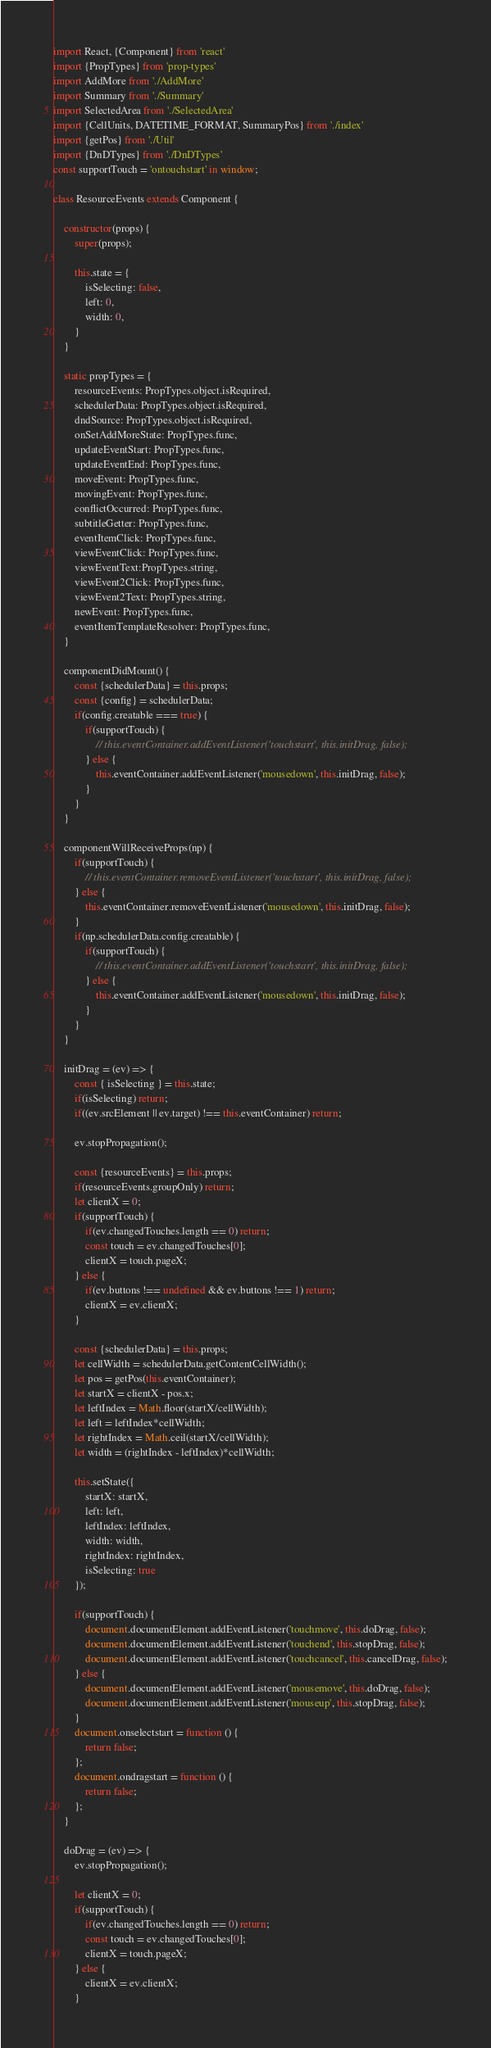<code> <loc_0><loc_0><loc_500><loc_500><_JavaScript_>import React, {Component} from 'react'
import {PropTypes} from 'prop-types'
import AddMore from './AddMore'
import Summary from './Summary'
import SelectedArea from './SelectedArea'
import {CellUnits, DATETIME_FORMAT, SummaryPos} from './index'
import {getPos} from './Util'
import {DnDTypes} from './DnDTypes'
const supportTouch = 'ontouchstart' in window;

class ResourceEvents extends Component {

    constructor(props) {
        super(props);

        this.state = {
            isSelecting: false,
            left: 0,
            width: 0,
        }
    }

    static propTypes = {
        resourceEvents: PropTypes.object.isRequired,
        schedulerData: PropTypes.object.isRequired,
        dndSource: PropTypes.object.isRequired,
        onSetAddMoreState: PropTypes.func,
        updateEventStart: PropTypes.func,
        updateEventEnd: PropTypes.func,
        moveEvent: PropTypes.func,
        movingEvent: PropTypes.func,
        conflictOccurred: PropTypes.func,
        subtitleGetter: PropTypes.func,
        eventItemClick: PropTypes.func,
        viewEventClick: PropTypes.func,
        viewEventText:PropTypes.string,
        viewEvent2Click: PropTypes.func,
        viewEvent2Text: PropTypes.string,
        newEvent: PropTypes.func,
        eventItemTemplateResolver: PropTypes.func,
    }

    componentDidMount() {
        const {schedulerData} = this.props;
        const {config} = schedulerData;
        if(config.creatable === true) {
            if(supportTouch) {
                // this.eventContainer.addEventListener('touchstart', this.initDrag, false);
            } else {
                this.eventContainer.addEventListener('mousedown', this.initDrag, false);
            }            
        }
    }

    componentWillReceiveProps(np) {
        if(supportTouch) {
            // this.eventContainer.removeEventListener('touchstart', this.initDrag, false);
        } else {
            this.eventContainer.removeEventListener('mousedown', this.initDrag, false);
        }        
        if(np.schedulerData.config.creatable) {
            if(supportTouch) {
                // this.eventContainer.addEventListener('touchstart', this.initDrag, false);
            } else {
                this.eventContainer.addEventListener('mousedown', this.initDrag, false);
            }
        }            
    }

    initDrag = (ev) => {
        const { isSelecting } = this.state;
        if(isSelecting) return;
        if((ev.srcElement || ev.target) !== this.eventContainer) return;

        ev.stopPropagation();
        
        const {resourceEvents} = this.props;
        if(resourceEvents.groupOnly) return;
        let clientX = 0;
        if(supportTouch) {
            if(ev.changedTouches.length == 0) return;
            const touch = ev.changedTouches[0];
            clientX = touch.pageX;
        } else {
            if(ev.buttons !== undefined && ev.buttons !== 1) return;
            clientX = ev.clientX;
        }

        const {schedulerData} = this.props;
        let cellWidth = schedulerData.getContentCellWidth();
        let pos = getPos(this.eventContainer);
        let startX = clientX - pos.x;
        let leftIndex = Math.floor(startX/cellWidth);
        let left = leftIndex*cellWidth;
        let rightIndex = Math.ceil(startX/cellWidth);
        let width = (rightIndex - leftIndex)*cellWidth;

        this.setState({
            startX: startX,
            left: left,
            leftIndex: leftIndex,
            width: width,
            rightIndex: rightIndex,
            isSelecting: true
        });

        if(supportTouch) {
            document.documentElement.addEventListener('touchmove', this.doDrag, false);
            document.documentElement.addEventListener('touchend', this.stopDrag, false);
            document.documentElement.addEventListener('touchcancel', this.cancelDrag, false);
        } else {
            document.documentElement.addEventListener('mousemove', this.doDrag, false);
            document.documentElement.addEventListener('mouseup', this.stopDrag, false);
        }
        document.onselectstart = function () {
			return false;
		};
		document.ondragstart = function () {
			return false;
		};
    }

    doDrag = (ev) => {
        ev.stopPropagation();

        let clientX = 0;
        if(supportTouch) {
            if(ev.changedTouches.length == 0) return;
            const touch = ev.changedTouches[0];
            clientX = touch.pageX;
        } else {
            clientX = ev.clientX;
        }</code> 